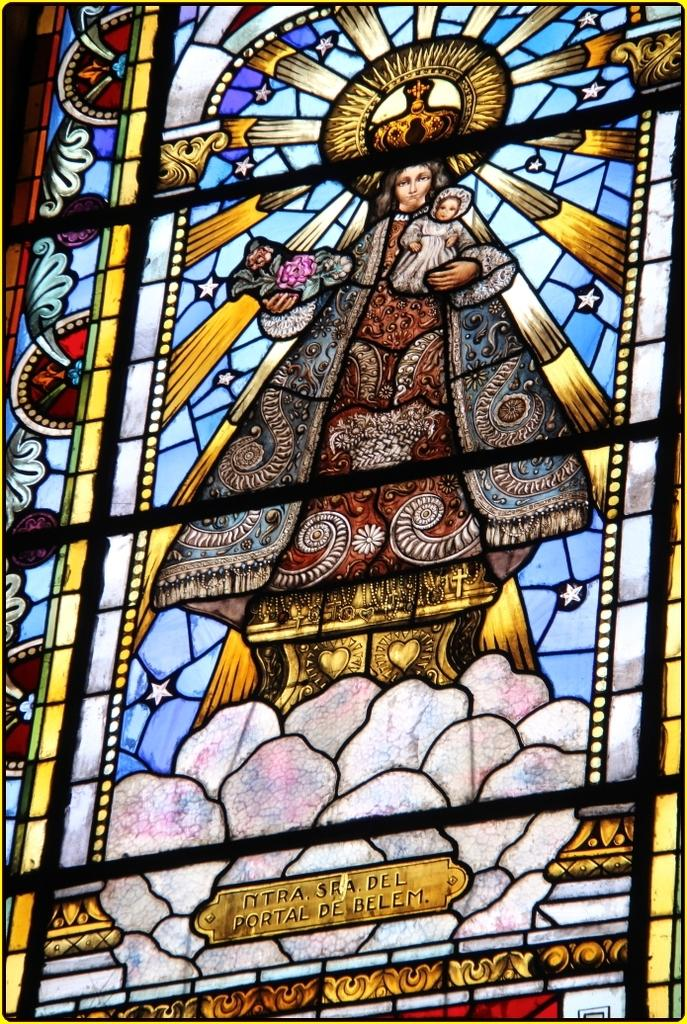What object is present in the image? There is a glass in the image. What is depicted on the glass? There is a Jesus painting on the glass. How many chickens can be seen comfortably sitting on the pizzas in the image? There are no chickens or pizzas present in the image. 